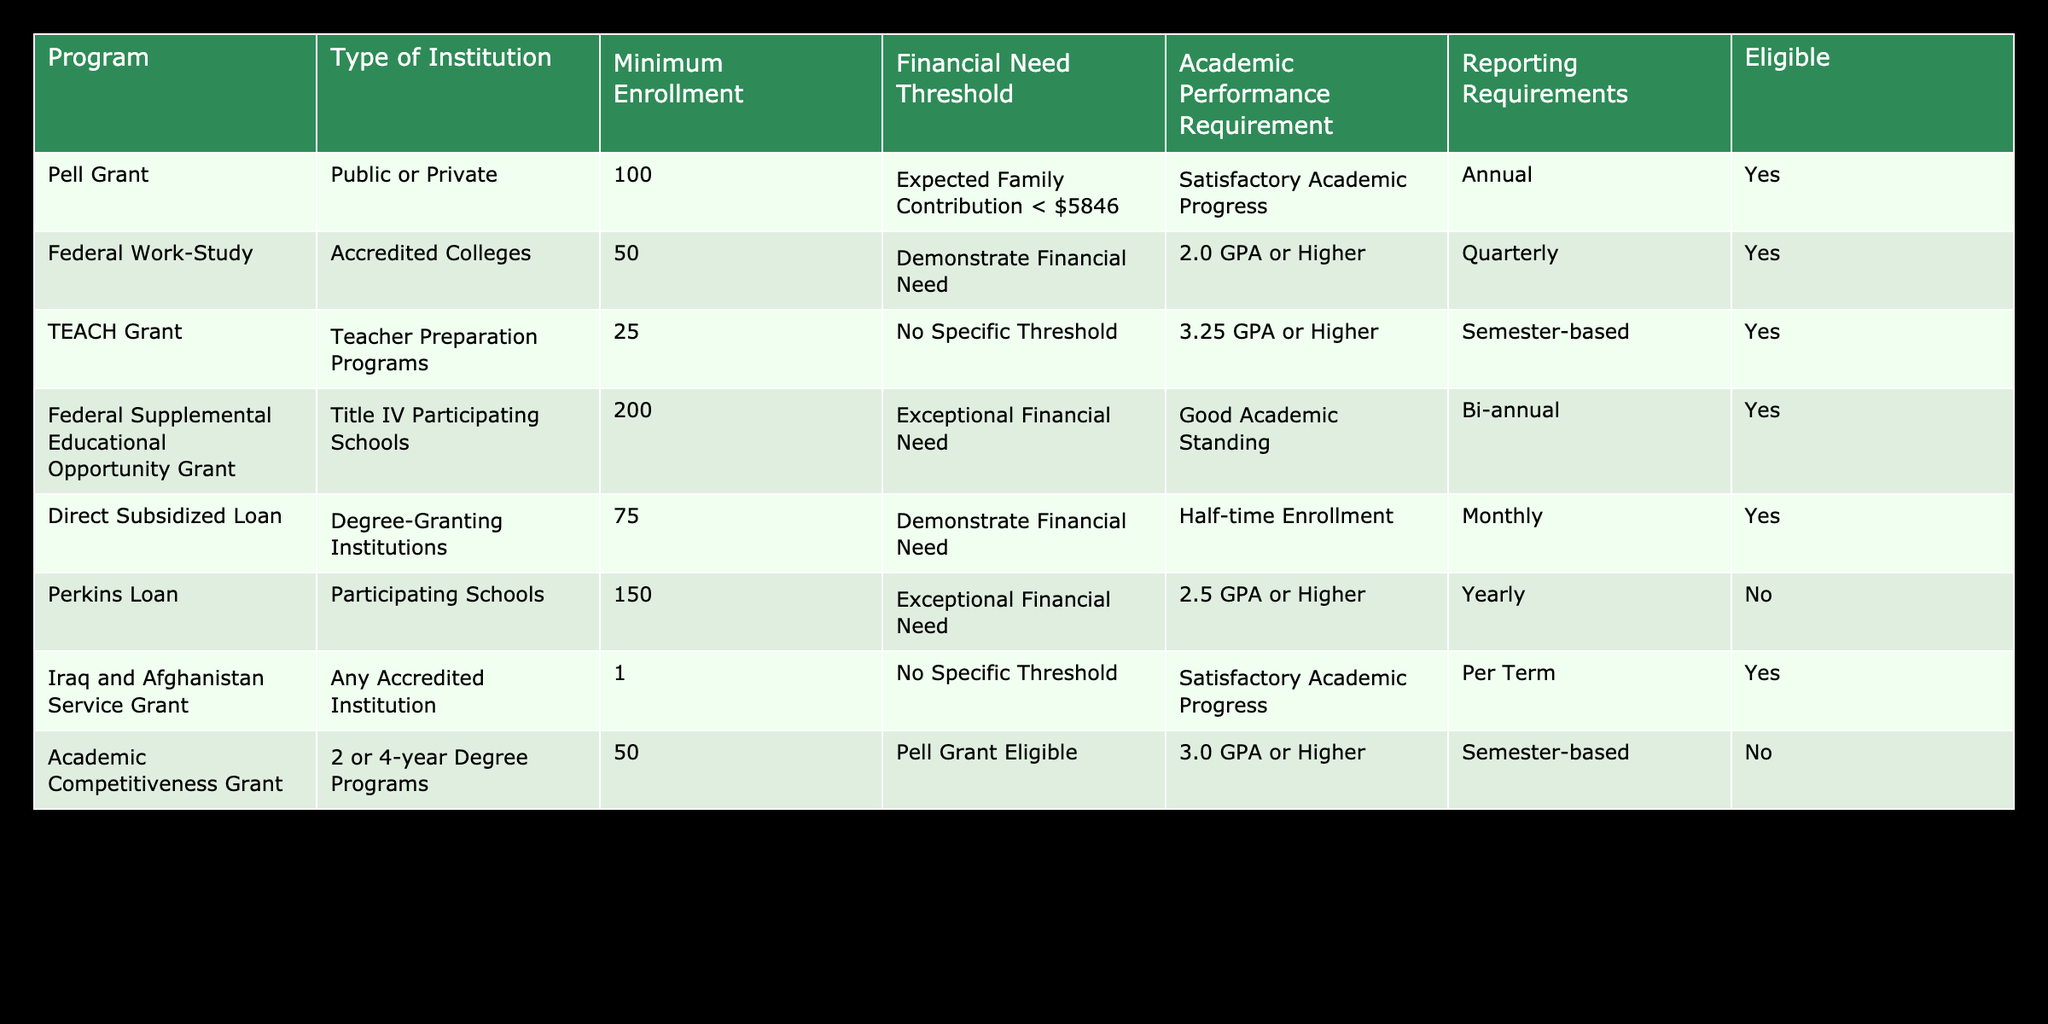What is the minimum enrollment requirement for the Pell Grant? The Pell Grant has a minimum enrollment requirement of 100 students, which can be directly found in the 'Minimum Enrollment' column of the Pell Grant row in the table.
Answer: 100 Which program requires the highest minimum enrollment? The program with the highest minimum enrollment requirement is the Federal Supplemental Educational Opportunity Grant, which requires 200 students as seen in the 'Minimum Enrollment' column.
Answer: 200 Are students with a GPA below 2.0 eligible for the Federal Work-Study? No, the eligibility for the Federal Work-Study requires a minimum GPA of 2.0 or higher as specified in the 'Academic Performance Requirement' column for that program.
Answer: No What is the Financial Need Threshold for the Direct Subsidized Loan? The Direct Subsidized Loan requires students to demonstrate financial need, as stated in the 'Financial Need Threshold' column for this program.
Answer: Demonstrate Financial Need Which programs have reporting requirements on a quarterly basis? The only program with quarterly reporting requirements is the Federal Work-Study, which can be found in the 'Reporting Requirements' column of that specific row.
Answer: Federal Work-Study Calculate the average minimum enrollment requirement for all programs that require at least 100 enrolled students. The programs that require at least 100 enrolled students are Pell Grant (100), Federal Supplemental Educational Opportunity Grant (200), Direct Subsidized Loan (75), and Perkins Loan (150). Adding these values gives 100 + 200 + 75 + 150 = 525, and there are 4 programs, so the average minimum enrollment is 525 / 4 = 131.25.
Answer: 131.25 How many programs do not have satisfactory academic progress as their performance requirement? Two programs: Perkins Loan and Academic Competitiveness Grant do not have satisfactory academic progress as their academic performance requirement. The counts can be identified by checking the 'Academic Performance Requirement' column for these programs.
Answer: 2 Which type of institution is eligible for the Iraq and Afghanistan Service Grant? The Iraq and Afghanistan Service Grant can be used at any accredited institution, as indicated in the 'Type of Institution' column of that entry.
Answer: Any Accredited Institution Is the TEACH Grant available for institutions with fewer than 25 enrollments? No, the TEACH Grant has a minimum enrollment requirement of 25 students; thus, institutions with fewer than this number are not eligible based on the 'Minimum Enrollment' requirement in that row.
Answer: No 